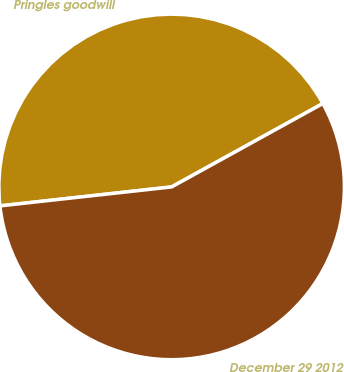Convert chart to OTSL. <chart><loc_0><loc_0><loc_500><loc_500><pie_chart><fcel>Pringles goodwill<fcel>December 29 2012<nl><fcel>43.73%<fcel>56.27%<nl></chart> 